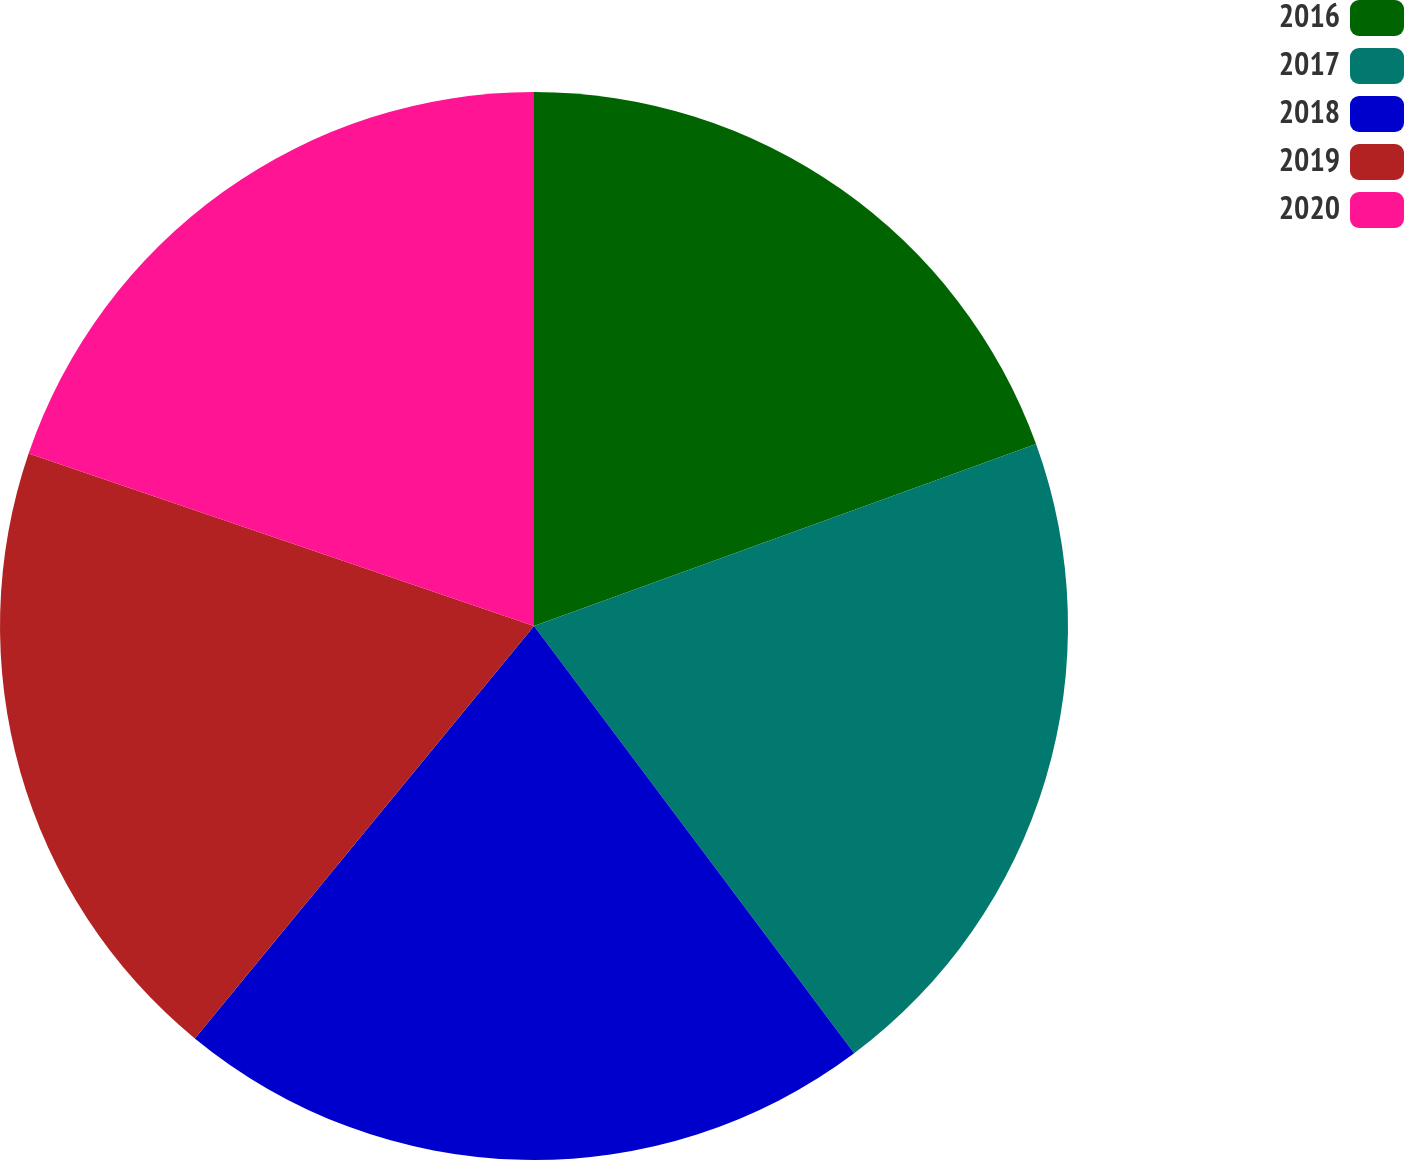Convert chart to OTSL. <chart><loc_0><loc_0><loc_500><loc_500><pie_chart><fcel>2016<fcel>2017<fcel>2018<fcel>2019<fcel>2020<nl><fcel>19.47%<fcel>20.3%<fcel>21.19%<fcel>19.28%<fcel>19.77%<nl></chart> 